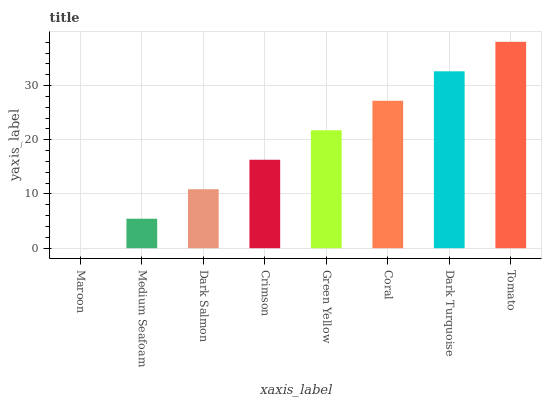Is Medium Seafoam the minimum?
Answer yes or no. No. Is Medium Seafoam the maximum?
Answer yes or no. No. Is Medium Seafoam greater than Maroon?
Answer yes or no. Yes. Is Maroon less than Medium Seafoam?
Answer yes or no. Yes. Is Maroon greater than Medium Seafoam?
Answer yes or no. No. Is Medium Seafoam less than Maroon?
Answer yes or no. No. Is Green Yellow the high median?
Answer yes or no. Yes. Is Crimson the low median?
Answer yes or no. Yes. Is Dark Salmon the high median?
Answer yes or no. No. Is Green Yellow the low median?
Answer yes or no. No. 